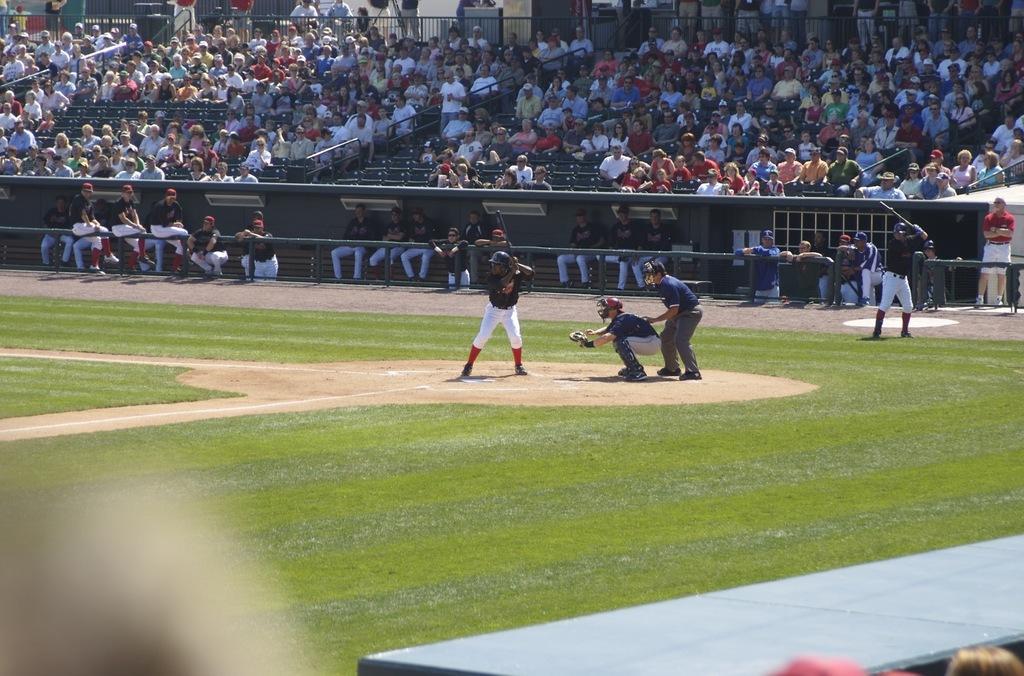How would you summarize this image in a sentence or two? In the center of the image there are people playing baseball. At the bottom of the image there is grass. In the background of the image there are audience sitting stands and watching the game. There is a fencing. 